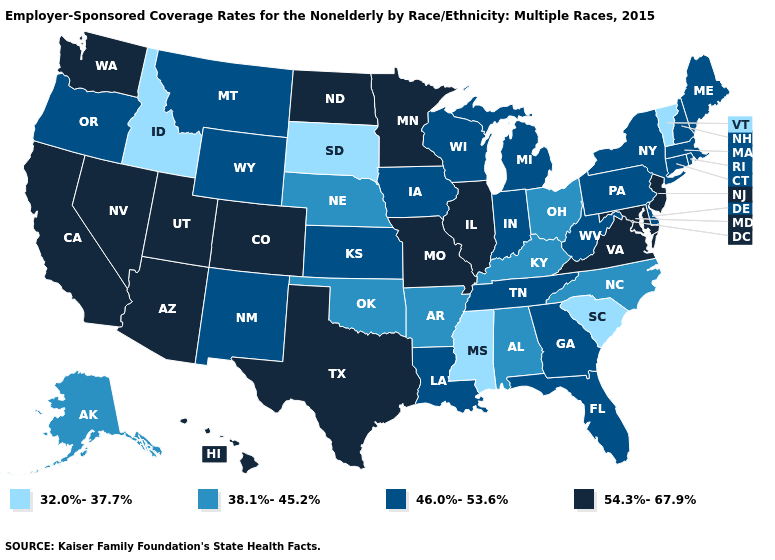What is the value of Arizona?
Write a very short answer. 54.3%-67.9%. What is the value of Oklahoma?
Concise answer only. 38.1%-45.2%. What is the value of Colorado?
Quick response, please. 54.3%-67.9%. Name the states that have a value in the range 32.0%-37.7%?
Quick response, please. Idaho, Mississippi, South Carolina, South Dakota, Vermont. What is the value of Georgia?
Answer briefly. 46.0%-53.6%. Does the map have missing data?
Concise answer only. No. What is the lowest value in states that border Arizona?
Give a very brief answer. 46.0%-53.6%. Which states have the lowest value in the USA?
Keep it brief. Idaho, Mississippi, South Carolina, South Dakota, Vermont. Name the states that have a value in the range 54.3%-67.9%?
Concise answer only. Arizona, California, Colorado, Hawaii, Illinois, Maryland, Minnesota, Missouri, Nevada, New Jersey, North Dakota, Texas, Utah, Virginia, Washington. Does Iowa have the lowest value in the USA?
Quick response, please. No. What is the value of Minnesota?
Give a very brief answer. 54.3%-67.9%. Name the states that have a value in the range 32.0%-37.7%?
Concise answer only. Idaho, Mississippi, South Carolina, South Dakota, Vermont. What is the lowest value in states that border North Dakota?
Give a very brief answer. 32.0%-37.7%. What is the highest value in the South ?
Quick response, please. 54.3%-67.9%. Which states hav the highest value in the West?
Be succinct. Arizona, California, Colorado, Hawaii, Nevada, Utah, Washington. 